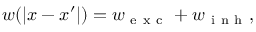<formula> <loc_0><loc_0><loc_500><loc_500>w ( | x - x ^ { \prime } | ) = w _ { e x c } + w _ { i n h } ,</formula> 